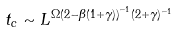Convert formula to latex. <formula><loc_0><loc_0><loc_500><loc_500>t _ { c } \sim L ^ { \Omega \left ( 2 - \beta ( 1 + \gamma ) \right ) ^ { - 1 } ( 2 + \gamma ) ^ { - 1 } }</formula> 